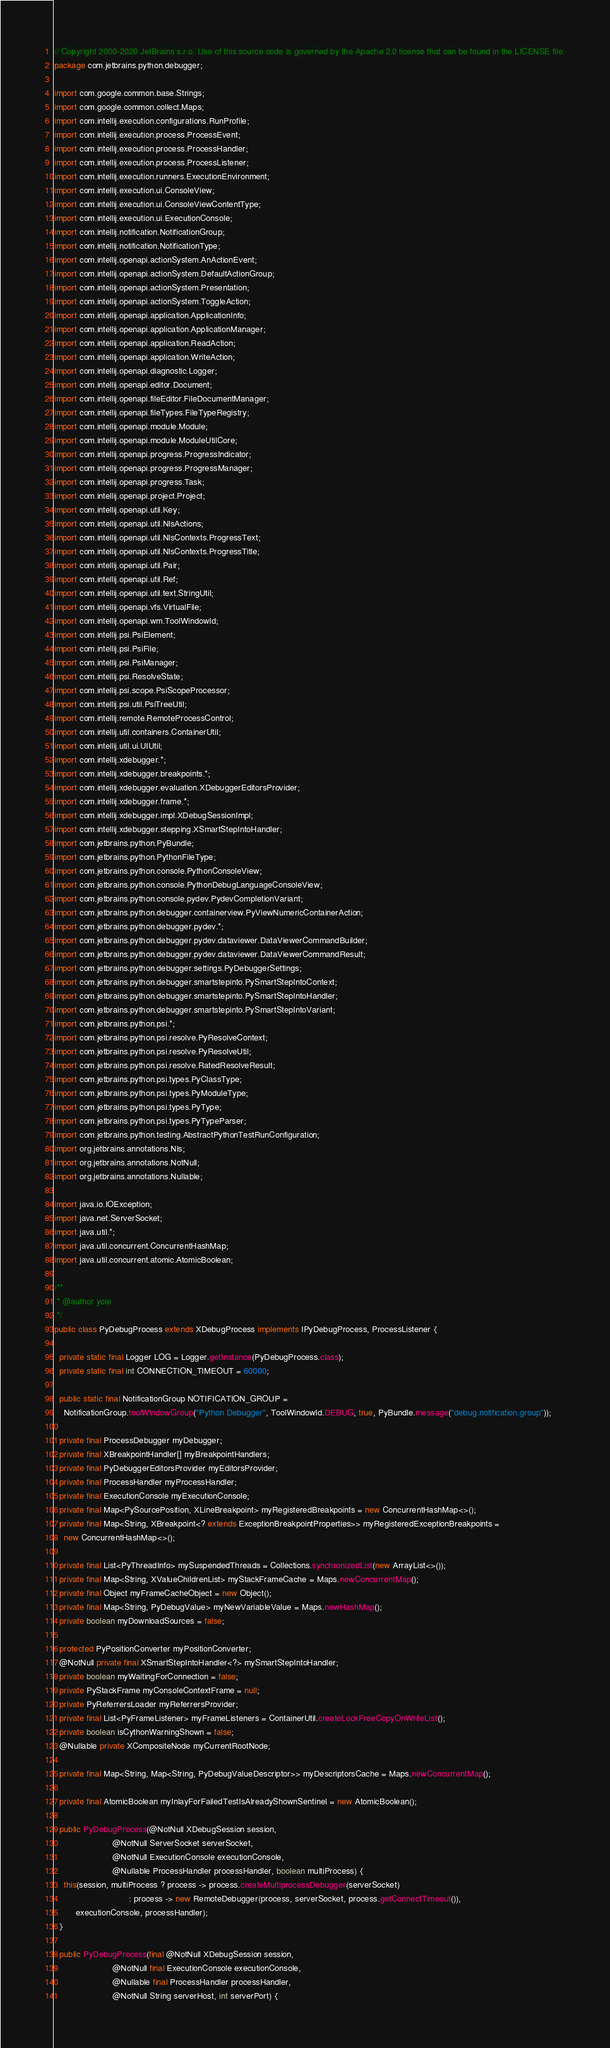Convert code to text. <code><loc_0><loc_0><loc_500><loc_500><_Java_>// Copyright 2000-2020 JetBrains s.r.o. Use of this source code is governed by the Apache 2.0 license that can be found in the LICENSE file.
package com.jetbrains.python.debugger;

import com.google.common.base.Strings;
import com.google.common.collect.Maps;
import com.intellij.execution.configurations.RunProfile;
import com.intellij.execution.process.ProcessEvent;
import com.intellij.execution.process.ProcessHandler;
import com.intellij.execution.process.ProcessListener;
import com.intellij.execution.runners.ExecutionEnvironment;
import com.intellij.execution.ui.ConsoleView;
import com.intellij.execution.ui.ConsoleViewContentType;
import com.intellij.execution.ui.ExecutionConsole;
import com.intellij.notification.NotificationGroup;
import com.intellij.notification.NotificationType;
import com.intellij.openapi.actionSystem.AnActionEvent;
import com.intellij.openapi.actionSystem.DefaultActionGroup;
import com.intellij.openapi.actionSystem.Presentation;
import com.intellij.openapi.actionSystem.ToggleAction;
import com.intellij.openapi.application.ApplicationInfo;
import com.intellij.openapi.application.ApplicationManager;
import com.intellij.openapi.application.ReadAction;
import com.intellij.openapi.application.WriteAction;
import com.intellij.openapi.diagnostic.Logger;
import com.intellij.openapi.editor.Document;
import com.intellij.openapi.fileEditor.FileDocumentManager;
import com.intellij.openapi.fileTypes.FileTypeRegistry;
import com.intellij.openapi.module.Module;
import com.intellij.openapi.module.ModuleUtilCore;
import com.intellij.openapi.progress.ProgressIndicator;
import com.intellij.openapi.progress.ProgressManager;
import com.intellij.openapi.progress.Task;
import com.intellij.openapi.project.Project;
import com.intellij.openapi.util.Key;
import com.intellij.openapi.util.NlsActions;
import com.intellij.openapi.util.NlsContexts.ProgressText;
import com.intellij.openapi.util.NlsContexts.ProgressTitle;
import com.intellij.openapi.util.Pair;
import com.intellij.openapi.util.Ref;
import com.intellij.openapi.util.text.StringUtil;
import com.intellij.openapi.vfs.VirtualFile;
import com.intellij.openapi.wm.ToolWindowId;
import com.intellij.psi.PsiElement;
import com.intellij.psi.PsiFile;
import com.intellij.psi.PsiManager;
import com.intellij.psi.ResolveState;
import com.intellij.psi.scope.PsiScopeProcessor;
import com.intellij.psi.util.PsiTreeUtil;
import com.intellij.remote.RemoteProcessControl;
import com.intellij.util.containers.ContainerUtil;
import com.intellij.util.ui.UIUtil;
import com.intellij.xdebugger.*;
import com.intellij.xdebugger.breakpoints.*;
import com.intellij.xdebugger.evaluation.XDebuggerEditorsProvider;
import com.intellij.xdebugger.frame.*;
import com.intellij.xdebugger.impl.XDebugSessionImpl;
import com.intellij.xdebugger.stepping.XSmartStepIntoHandler;
import com.jetbrains.python.PyBundle;
import com.jetbrains.python.PythonFileType;
import com.jetbrains.python.console.PythonConsoleView;
import com.jetbrains.python.console.PythonDebugLanguageConsoleView;
import com.jetbrains.python.console.pydev.PydevCompletionVariant;
import com.jetbrains.python.debugger.containerview.PyViewNumericContainerAction;
import com.jetbrains.python.debugger.pydev.*;
import com.jetbrains.python.debugger.pydev.dataviewer.DataViewerCommandBuilder;
import com.jetbrains.python.debugger.pydev.dataviewer.DataViewerCommandResult;
import com.jetbrains.python.debugger.settings.PyDebuggerSettings;
import com.jetbrains.python.debugger.smartstepinto.PySmartStepIntoContext;
import com.jetbrains.python.debugger.smartstepinto.PySmartStepIntoHandler;
import com.jetbrains.python.debugger.smartstepinto.PySmartStepIntoVariant;
import com.jetbrains.python.psi.*;
import com.jetbrains.python.psi.resolve.PyResolveContext;
import com.jetbrains.python.psi.resolve.PyResolveUtil;
import com.jetbrains.python.psi.resolve.RatedResolveResult;
import com.jetbrains.python.psi.types.PyClassType;
import com.jetbrains.python.psi.types.PyModuleType;
import com.jetbrains.python.psi.types.PyType;
import com.jetbrains.python.psi.types.PyTypeParser;
import com.jetbrains.python.testing.AbstractPythonTestRunConfiguration;
import org.jetbrains.annotations.Nls;
import org.jetbrains.annotations.NotNull;
import org.jetbrains.annotations.Nullable;

import java.io.IOException;
import java.net.ServerSocket;
import java.util.*;
import java.util.concurrent.ConcurrentHashMap;
import java.util.concurrent.atomic.AtomicBoolean;

/**
 * @author yole
 */
public class PyDebugProcess extends XDebugProcess implements IPyDebugProcess, ProcessListener {

  private static final Logger LOG = Logger.getInstance(PyDebugProcess.class);
  private static final int CONNECTION_TIMEOUT = 60000;

  public static final NotificationGroup NOTIFICATION_GROUP =
    NotificationGroup.toolWindowGroup("Python Debugger", ToolWindowId.DEBUG, true, PyBundle.message("debug.notification.group"));

  private final ProcessDebugger myDebugger;
  private final XBreakpointHandler[] myBreakpointHandlers;
  private final PyDebuggerEditorsProvider myEditorsProvider;
  private final ProcessHandler myProcessHandler;
  private final ExecutionConsole myExecutionConsole;
  private final Map<PySourcePosition, XLineBreakpoint> myRegisteredBreakpoints = new ConcurrentHashMap<>();
  private final Map<String, XBreakpoint<? extends ExceptionBreakpointProperties>> myRegisteredExceptionBreakpoints =
    new ConcurrentHashMap<>();

  private final List<PyThreadInfo> mySuspendedThreads = Collections.synchronizedList(new ArrayList<>());
  private final Map<String, XValueChildrenList> myStackFrameCache = Maps.newConcurrentMap();
  private final Object myFrameCacheObject = new Object();
  private final Map<String, PyDebugValue> myNewVariableValue = Maps.newHashMap();
  private boolean myDownloadSources = false;

  protected PyPositionConverter myPositionConverter;
  @NotNull private final XSmartStepIntoHandler<?> mySmartStepIntoHandler;
  private boolean myWaitingForConnection = false;
  private PyStackFrame myConsoleContextFrame = null;
  private PyReferrersLoader myReferrersProvider;
  private final List<PyFrameListener> myFrameListeners = ContainerUtil.createLockFreeCopyOnWriteList();
  private boolean isCythonWarningShown = false;
  @Nullable private XCompositeNode myCurrentRootNode;

  private final Map<String, Map<String, PyDebugValueDescriptor>> myDescriptorsCache = Maps.newConcurrentMap();

  private final AtomicBoolean myInlayForFailedTestIsAlreadyShownSentinel = new AtomicBoolean();

  public PyDebugProcess(@NotNull XDebugSession session,
                        @NotNull ServerSocket serverSocket,
                        @NotNull ExecutionConsole executionConsole,
                        @Nullable ProcessHandler processHandler, boolean multiProcess) {
    this(session, multiProcess ? process -> process.createMultiprocessDebugger(serverSocket)
                               : process -> new RemoteDebugger(process, serverSocket, process.getConnectTimeout()),
         executionConsole, processHandler);
  }

  public PyDebugProcess(final @NotNull XDebugSession session,
                        @NotNull final ExecutionConsole executionConsole,
                        @Nullable final ProcessHandler processHandler,
                        @NotNull String serverHost, int serverPort) {</code> 